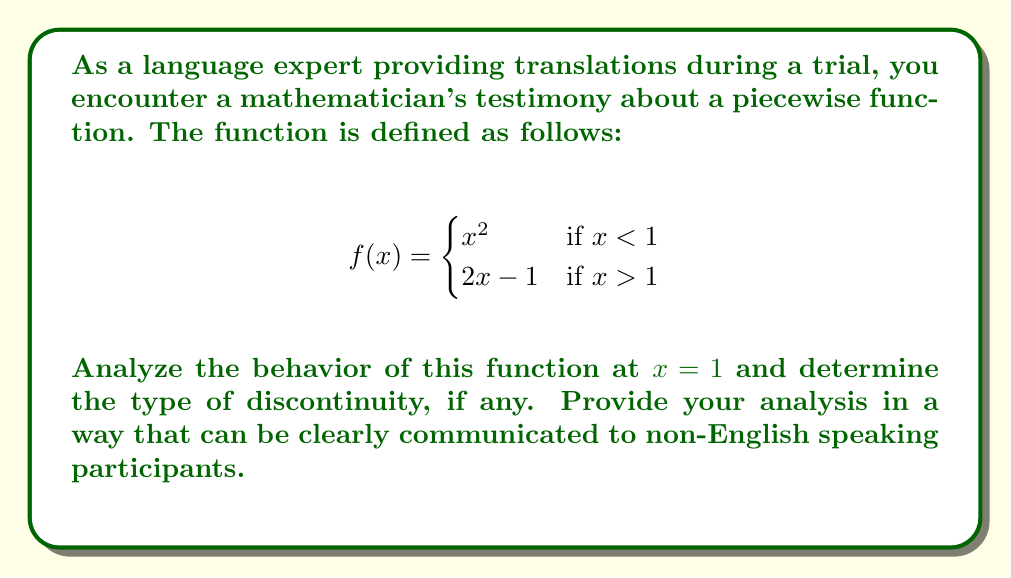Show me your answer to this math problem. To analyze the behavior of the piecewise function at $x = 1$, we need to follow these steps:

1) First, let's evaluate the left-hand limit:
   $\lim_{x \to 1^-} f(x) = \lim_{x \to 1^-} x^2 = 1^2 = 1$

2) Now, let's evaluate the right-hand limit:
   $\lim_{x \to 1^+} f(x) = \lim_{x \to 1^+} (2x - 1) = 2(1) - 1 = 1$

3) We see that both left-hand and right-hand limits exist and are equal:
   $\lim_{x \to 1^-} f(x) = \lim_{x \to 1^+} f(x) = 1$

4) However, the function is not defined at $x = 1$ in the given piecewise definition.

5) For a function to be continuous at a point, three conditions must be met:
   a) The left-hand limit exists
   b) The right-hand limit exists
   c) The function is defined at that point, and its value equals the left and right limits

6) In this case, conditions (a) and (b) are met, but condition (c) is not.

7) Therefore, this function has a removable discontinuity (also known as a point discontinuity) at $x = 1$.

8) Visually, this appears as a "hole" in the graph at the point (1,1).
Answer: Removable discontinuity at $x = 1$ 